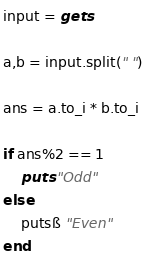Convert code to text. <code><loc_0><loc_0><loc_500><loc_500><_Ruby_>input = gets

a,b = input.split(" ")

ans = a.to_i * b.to_i

if ans%2 == 1
    puts "Odd"
else
    putsß "Even"
end</code> 